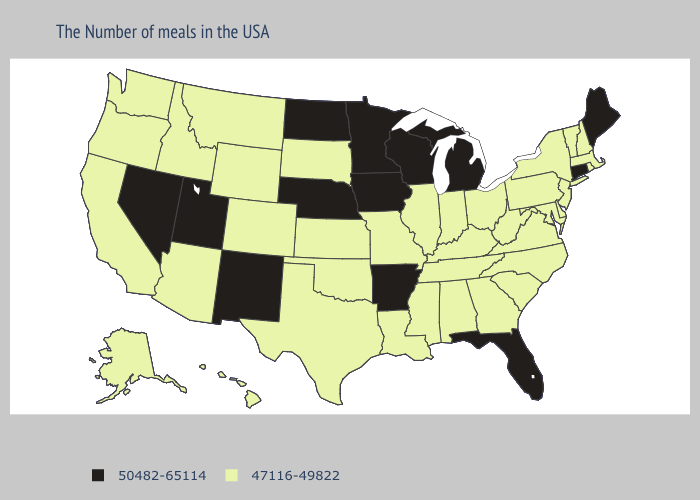Does Arkansas have the lowest value in the South?
Quick response, please. No. Does South Dakota have a lower value than Minnesota?
Keep it brief. Yes. Which states have the highest value in the USA?
Quick response, please. Maine, Connecticut, Florida, Michigan, Wisconsin, Arkansas, Minnesota, Iowa, Nebraska, North Dakota, New Mexico, Utah, Nevada. Which states hav the highest value in the MidWest?
Concise answer only. Michigan, Wisconsin, Minnesota, Iowa, Nebraska, North Dakota. Among the states that border Indiana , does Michigan have the highest value?
Keep it brief. Yes. What is the highest value in states that border Nevada?
Quick response, please. 50482-65114. What is the value of Georgia?
Keep it brief. 47116-49822. Is the legend a continuous bar?
Concise answer only. No. Does New York have the highest value in the USA?
Keep it brief. No. Name the states that have a value in the range 50482-65114?
Give a very brief answer. Maine, Connecticut, Florida, Michigan, Wisconsin, Arkansas, Minnesota, Iowa, Nebraska, North Dakota, New Mexico, Utah, Nevada. What is the value of Alaska?
Concise answer only. 47116-49822. What is the value of Texas?
Give a very brief answer. 47116-49822. What is the value of Alaska?
Quick response, please. 47116-49822. What is the highest value in the USA?
Keep it brief. 50482-65114. Among the states that border Oklahoma , does Arkansas have the lowest value?
Concise answer only. No. 